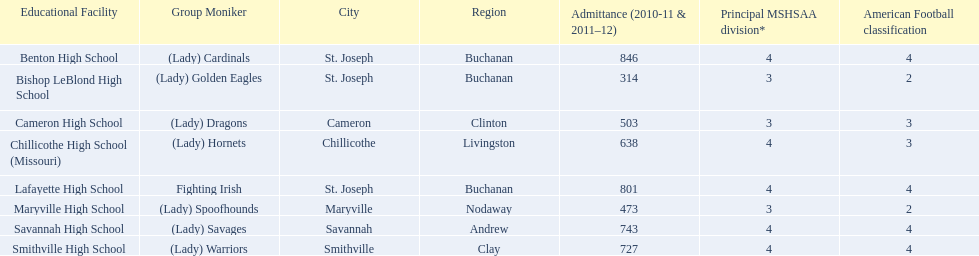What are the names of the schools? Benton High School, Bishop LeBlond High School, Cameron High School, Chillicothe High School (Missouri), Lafayette High School, Maryville High School, Savannah High School, Smithville High School. Of those, which had a total enrollment of less than 500? Bishop LeBlond High School, Maryville High School. And of those, which had the lowest enrollment? Bishop LeBlond High School. 